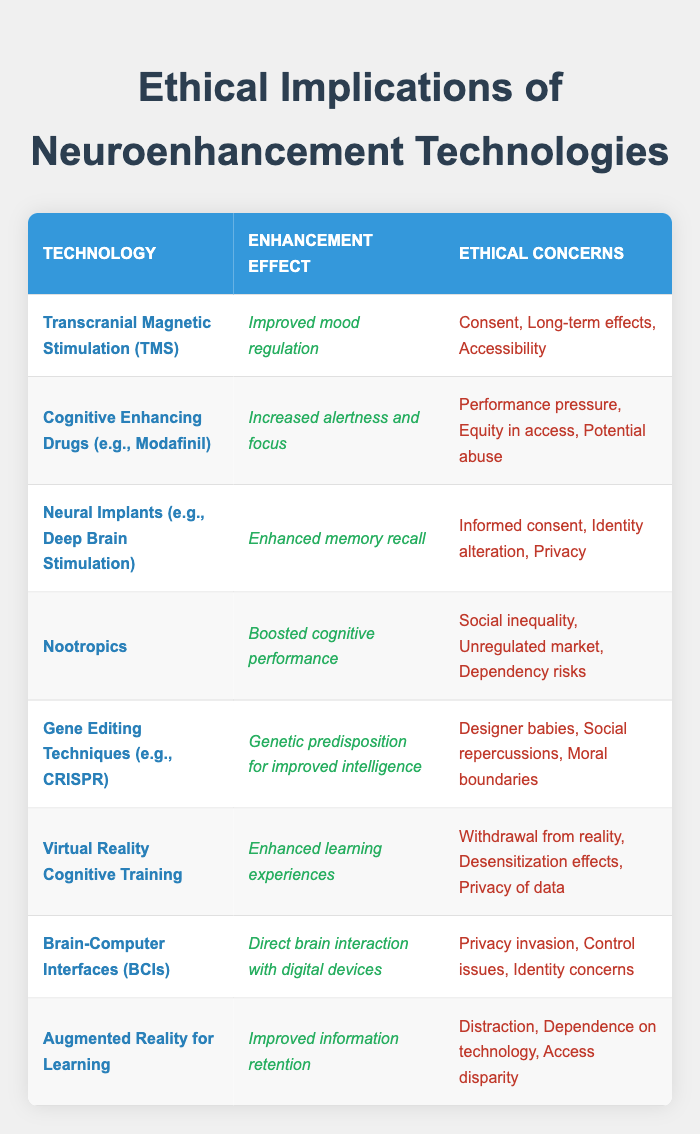What is the enhancement effect of Neural Implants? The table shows that Neural Implants (e.g., Deep Brain Stimulation) have the enhancement effect of "Enhanced memory recall."
Answer: Enhanced memory recall How many ethical concerns are listed for Nootropics? The table indicates that Nootropics have three ethical concerns listed: "Social inequality," "Unregulated market," and "Dependency risks." Therefore, there are three concerns.
Answer: Three Is there an ethical concern related to privacy for Brain-Computer Interfaces? Yes, according to the table, one of the ethical concerns for Brain-Computer Interfaces (BCIs) is "Privacy invasion," indicating that this concern is valid.
Answer: Yes Which technology has the enhancement effect of "Improved information retention"? The enhancement effect of "Improved information retention" is associated with "Augmented Reality for Learning," as stated in the table.
Answer: Augmented Reality for Learning Count the number of neuroenhancement technologies that have "Informed consent" as an ethical concern. The table highlights that only one technology, "Neural Implants (e.g., Deep Brain Stimulation)," lists "Informed consent" as an ethical concern. Therefore, the count is one.
Answer: One What are the ethical concerns for Cognitive Enhancing Drugs? The table presents three ethical concerns for Cognitive Enhancing Drugs (e.g., Modafinil): "Performance pressure," "Equity in access," and "Potential abuse."
Answer: Performance pressure, Equity in access, Potential abuse Does Gene Editing Techniques pose a concern related to social repercussions? Yes, the table notes that "Gene Editing Techniques (e.g., CRISPR)" has "Social repercussions" as one of its ethical concerns, indicating that this is a valid concern.
Answer: Yes Which technology involves a possible risk of identity alteration? According to the table, "Neural Implants (e.g., Deep Brain Stimulation)" includes "Identity alteration" among its ethical concerns, indicating a risk related to identity.
Answer: Neural Implants (e.g., Deep Brain Stimulation) What is the common ethical concern related to accessibility found in neuroenhancement technologies? The table shows that both "Transcranial Magnetic Stimulation (TMS)" and "Cognitive Enhancing Drugs (e.g., Modafinil)" list "Accessibility" and "Equity in access," respectively. The common theme is equal access to these technologies.
Answer: Accessibility 